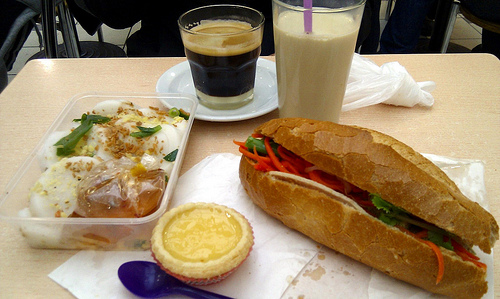<image>
Can you confirm if the cup is on the plate? No. The cup is not positioned on the plate. They may be near each other, but the cup is not supported by or resting on top of the plate. Is there a bahn mi behind the coffee? No. The bahn mi is not behind the coffee. From this viewpoint, the bahn mi appears to be positioned elsewhere in the scene. 